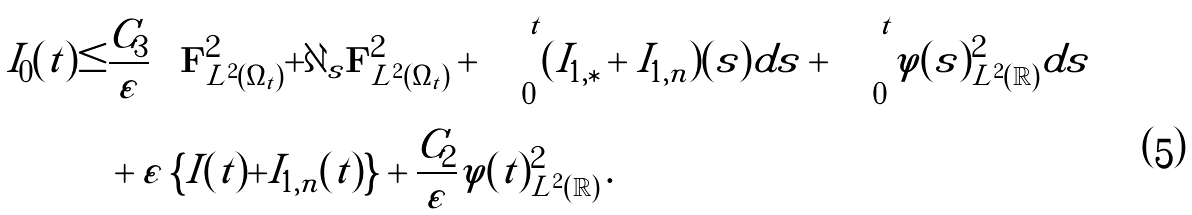<formula> <loc_0><loc_0><loc_500><loc_500>I _ { 0 } ( t ) \leq & \frac { C _ { 3 } } { \varepsilon } \left \{ \| { \mathbf F } \| ^ { 2 } _ { L ^ { 2 } ( \Omega _ { t } ) } + \| \partial _ { s } { \mathbf F } \| _ { L ^ { 2 } ( \Omega _ { t } ) } ^ { 2 } + \int _ { 0 } ^ { t } ( I _ { 1 , \ast } + I _ { 1 , n } ) ( s ) d s + \int _ { 0 } ^ { t } \| \varphi ( s ) \| _ { L ^ { 2 } ( \mathbb { R } ) } ^ { 2 } d s \right \} \\ & + \varepsilon \left \{ I ( t ) + I _ { 1 , n } ( t ) \right \} + \frac { C _ { 2 } } { \varepsilon } \| \varphi ( t ) \| _ { L ^ { 2 } ( \mathbb { R } ) } ^ { 2 } \, .</formula> 